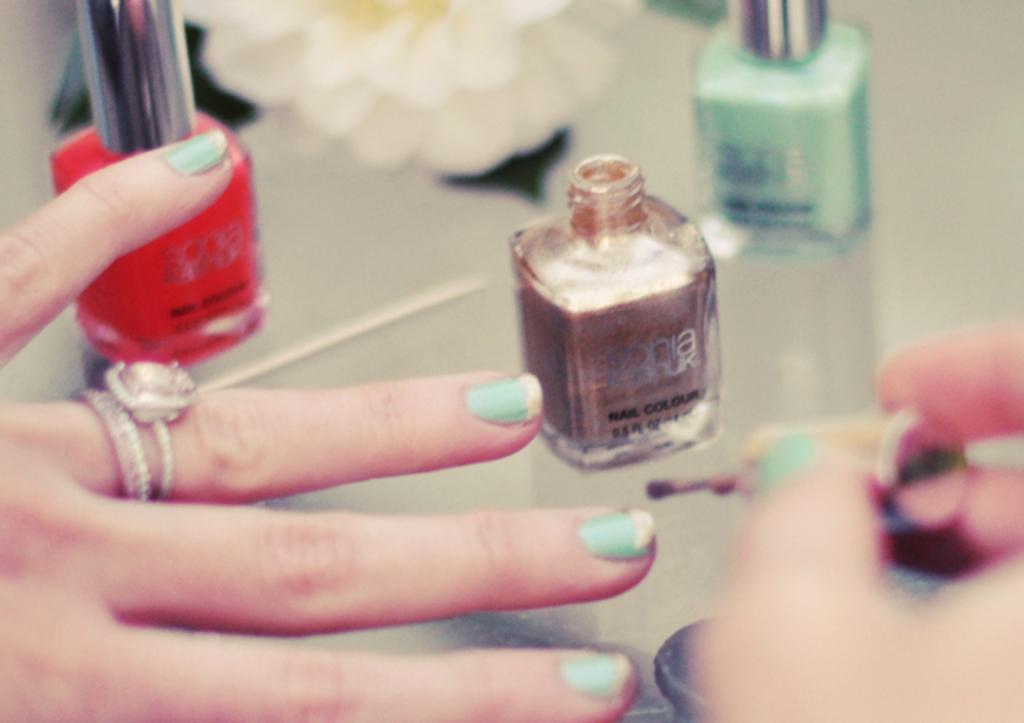<image>
Write a terse but informative summary of the picture. Three bottles of Sophia nail color are being used. 